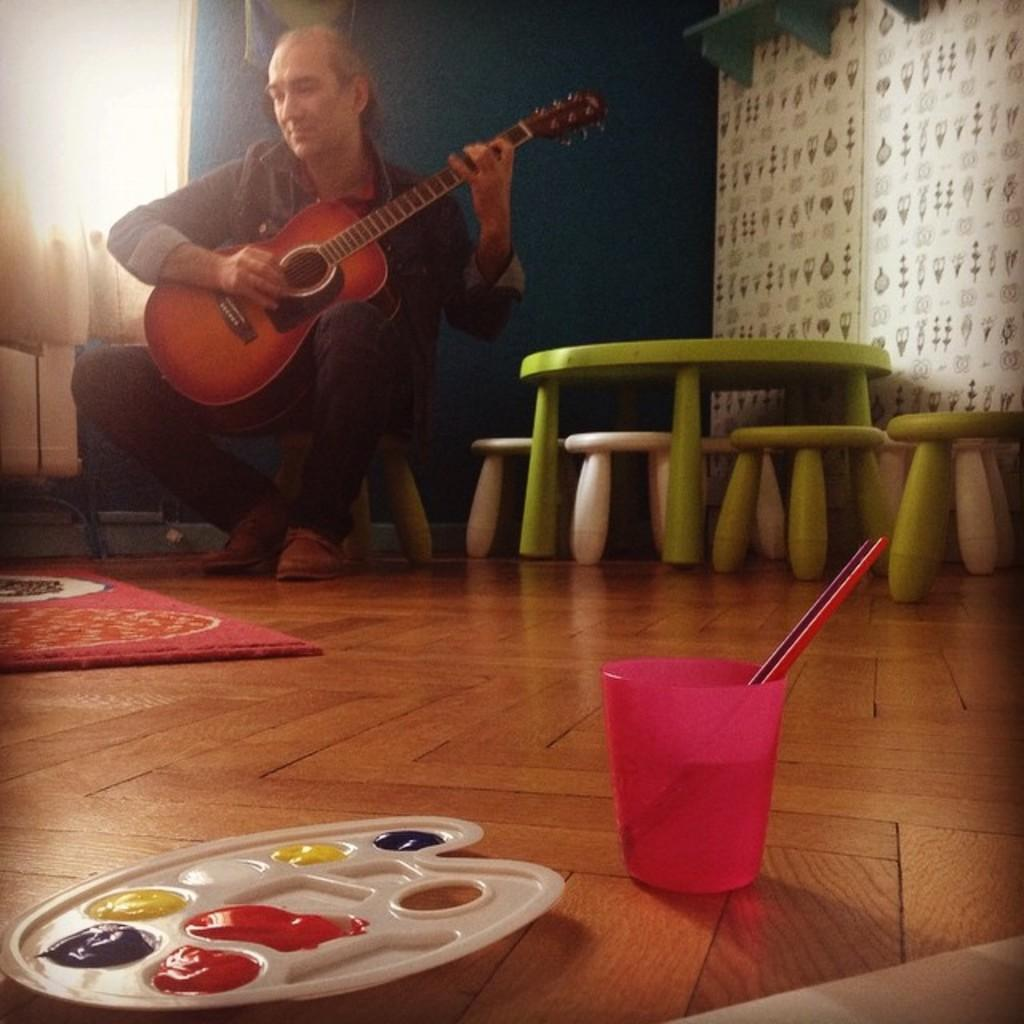What is the man in the image doing? The man is playing a guitar in the image. What is the man sitting on while playing the guitar? The man is sitting on a stool in the image. What other furniture is present in the image? There is a table and additional stools present in the image. Can you describe the colors visible in the image? Yes, there are colors visible in the image. What is the man holding while playing the guitar? The man is holding a glass in the image. What type of cord is the man using to play the guitar in the image? There is no cord visible in the image; the man is playing the guitar without any visible connection to an amplifier or other equipment. 